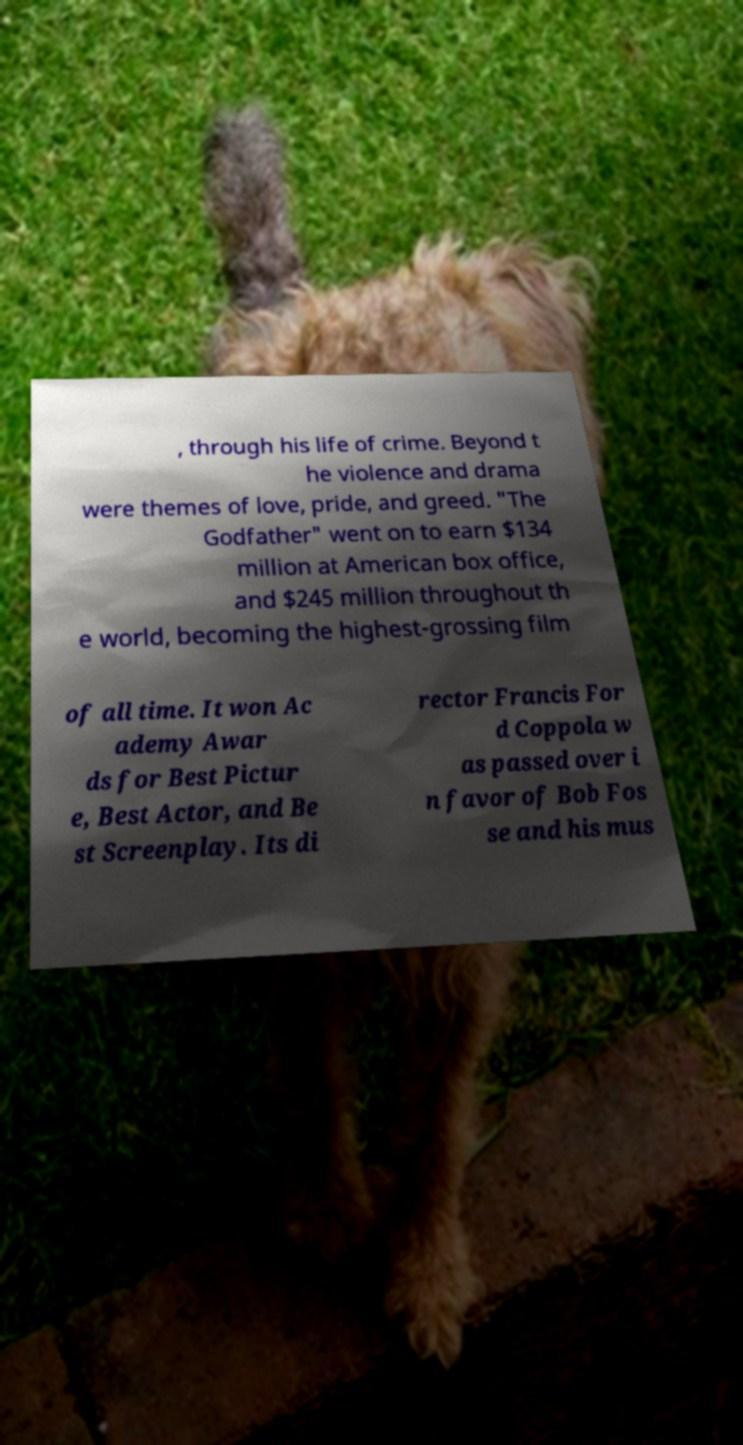Can you accurately transcribe the text from the provided image for me? , through his life of crime. Beyond t he violence and drama were themes of love, pride, and greed. "The Godfather" went on to earn $134 million at American box office, and $245 million throughout th e world, becoming the highest-grossing film of all time. It won Ac ademy Awar ds for Best Pictur e, Best Actor, and Be st Screenplay. Its di rector Francis For d Coppola w as passed over i n favor of Bob Fos se and his mus 